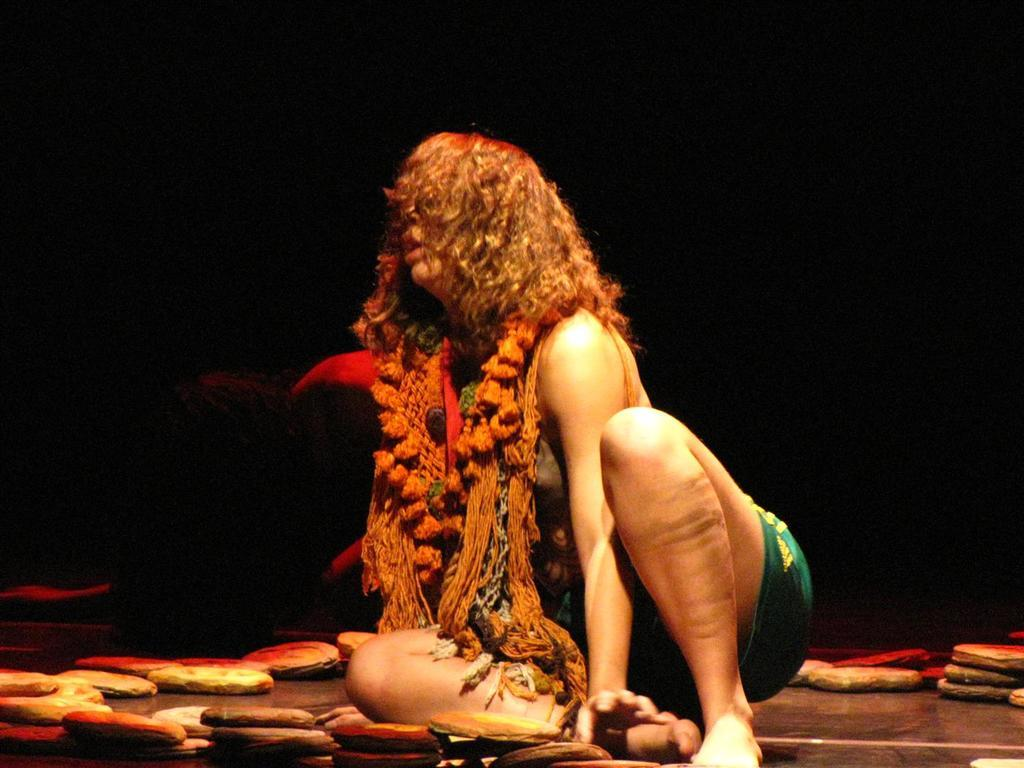What is the woman in the image doing? The woman is sitting on the floor in the image. What can be seen near the woman? There are many breads beside the woman. How would you describe the lighting in the image? The background of the image appears to be dark. How many toes does the woman have on her left foot in the image? The image does not provide enough detail to determine the number of toes on the woman's left foot. --- 